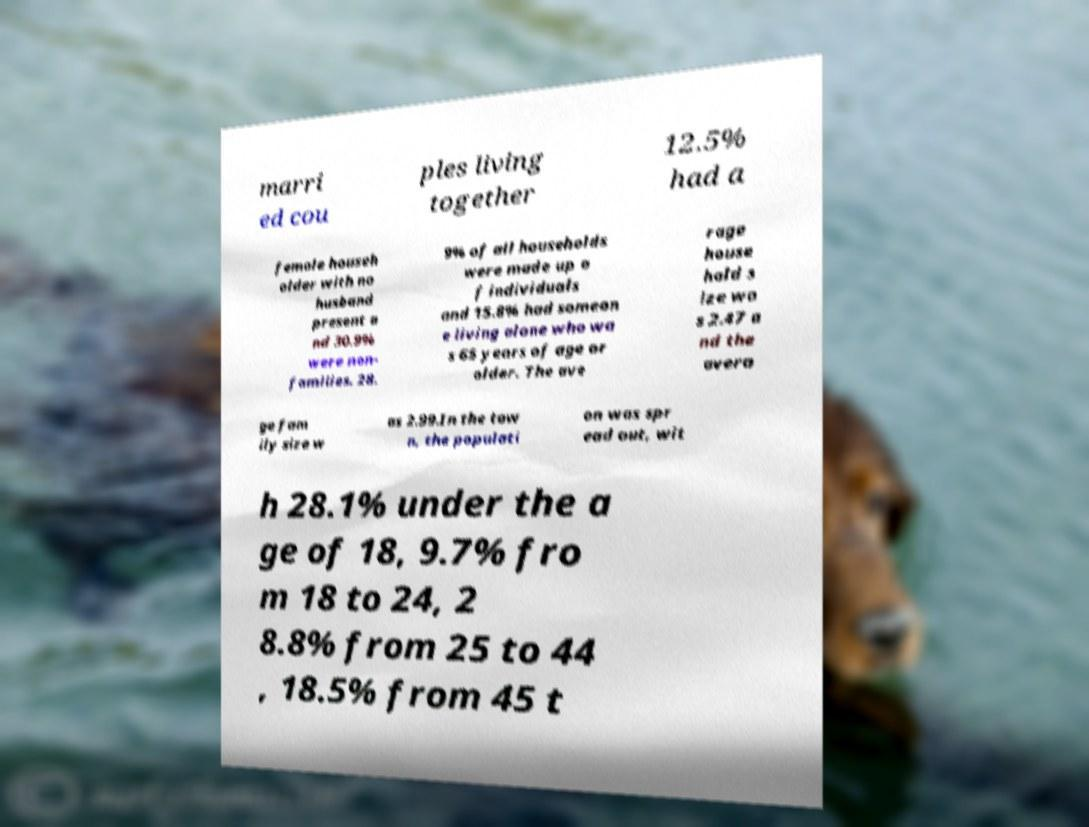Could you extract and type out the text from this image? marri ed cou ples living together 12.5% had a female househ older with no husband present a nd 30.9% were non- families. 28. 9% of all households were made up o f individuals and 15.8% had someon e living alone who wa s 65 years of age or older. The ave rage house hold s ize wa s 2.47 a nd the avera ge fam ily size w as 2.99.In the tow n, the populati on was spr ead out, wit h 28.1% under the a ge of 18, 9.7% fro m 18 to 24, 2 8.8% from 25 to 44 , 18.5% from 45 t 